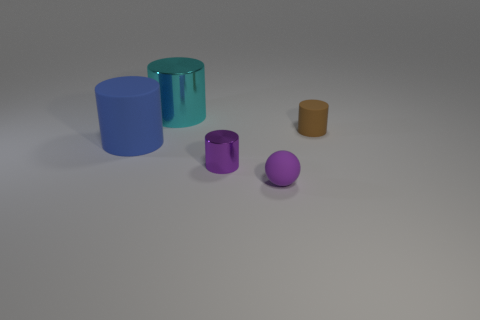The metal object to the left of the small purple object behind the small purple matte thing is what color?
Make the answer very short. Cyan. How many objects are things that are behind the tiny rubber sphere or blue rubber objects?
Your answer should be compact. 4. Do the brown rubber cylinder and the object on the left side of the large metallic thing have the same size?
Offer a very short reply. No. What number of tiny things are cyan metallic cylinders or purple objects?
Offer a very short reply. 2. What shape is the brown thing?
Offer a terse response. Cylinder. There is a matte object that is the same color as the small metal thing; what size is it?
Provide a short and direct response. Small. Is there a big gray object made of the same material as the brown cylinder?
Your answer should be compact. No. Are there more matte spheres than cylinders?
Offer a very short reply. No. Is the material of the large cyan cylinder the same as the tiny sphere?
Your response must be concise. No. What number of rubber objects are large yellow cubes or small cylinders?
Your answer should be compact. 1. 